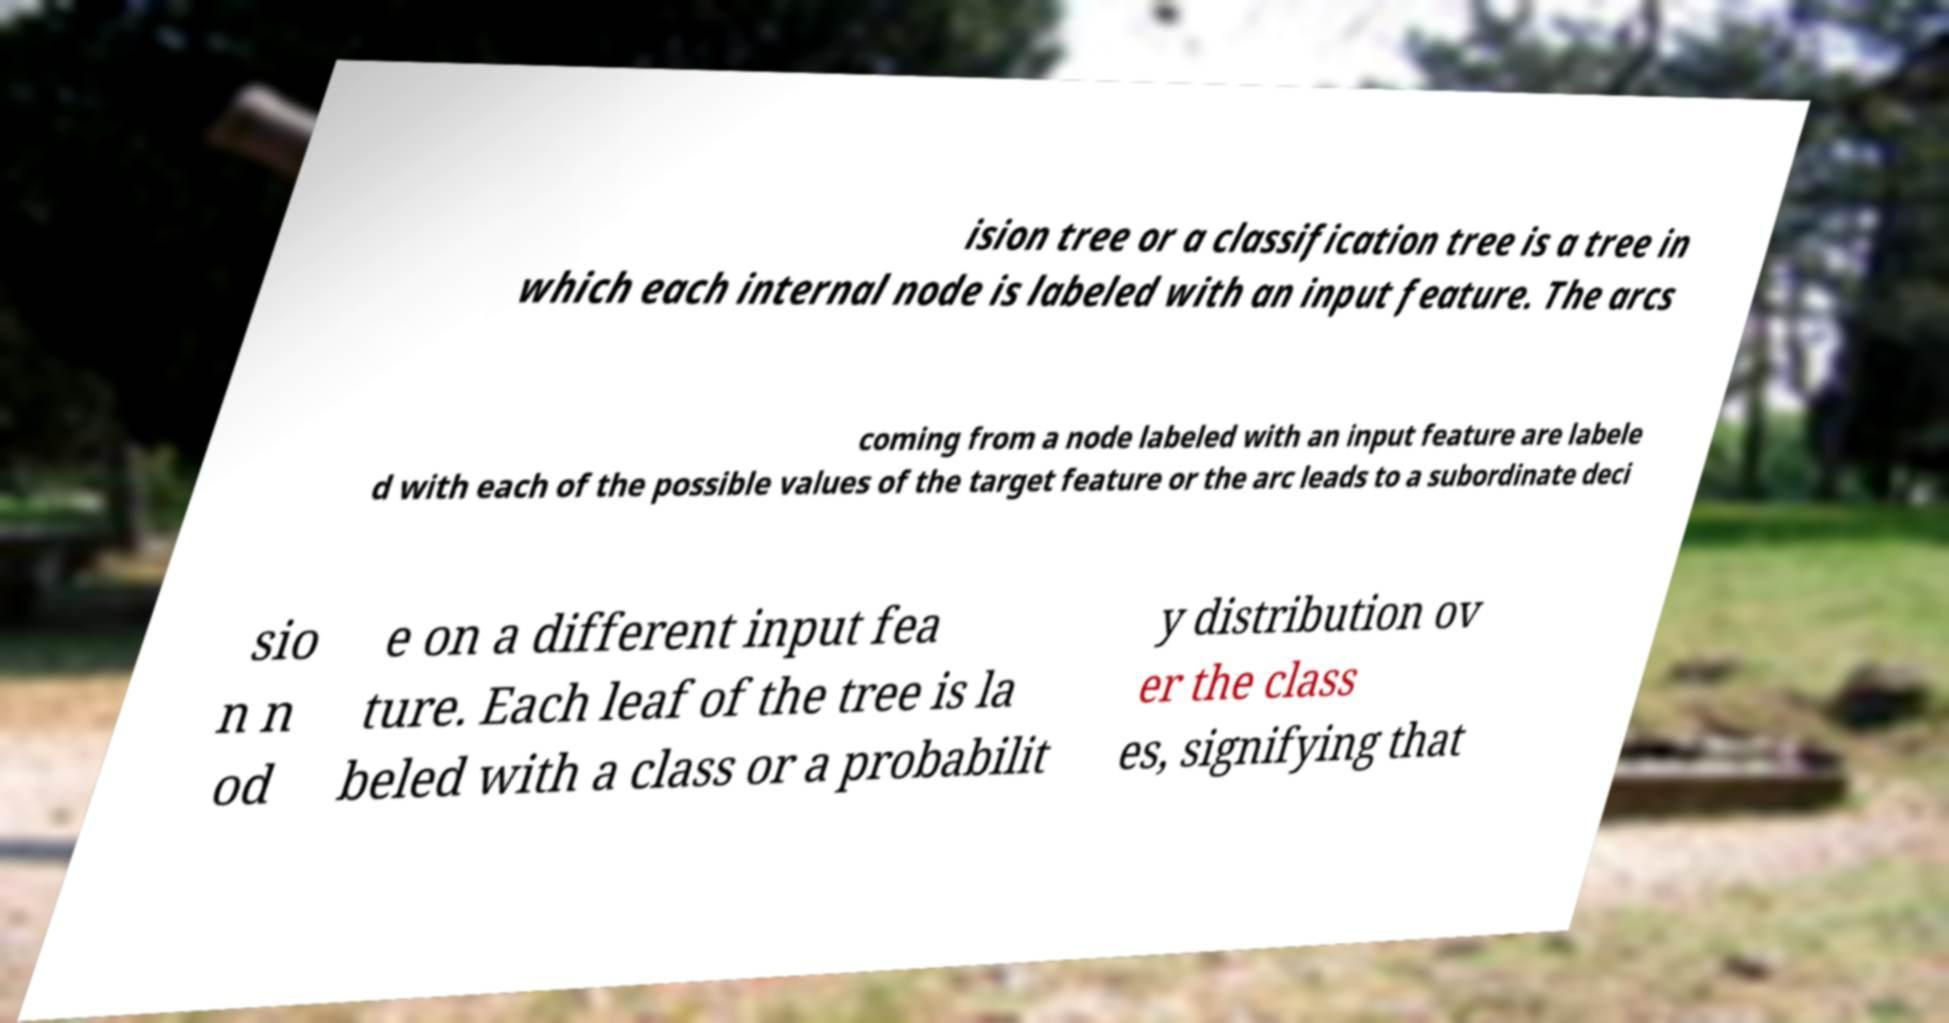Please identify and transcribe the text found in this image. ision tree or a classification tree is a tree in which each internal node is labeled with an input feature. The arcs coming from a node labeled with an input feature are labele d with each of the possible values of the target feature or the arc leads to a subordinate deci sio n n od e on a different input fea ture. Each leaf of the tree is la beled with a class or a probabilit y distribution ov er the class es, signifying that 